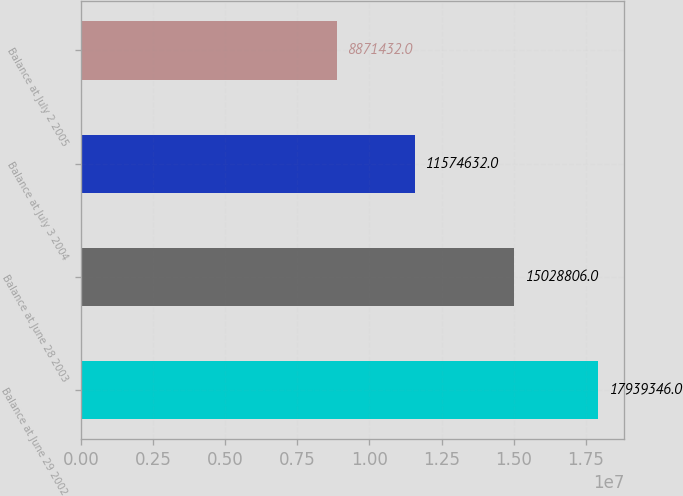Convert chart. <chart><loc_0><loc_0><loc_500><loc_500><bar_chart><fcel>Balance at June 29 2002<fcel>Balance at June 28 2003<fcel>Balance at July 3 2004<fcel>Balance at July 2 2005<nl><fcel>1.79393e+07<fcel>1.50288e+07<fcel>1.15746e+07<fcel>8.87143e+06<nl></chart> 